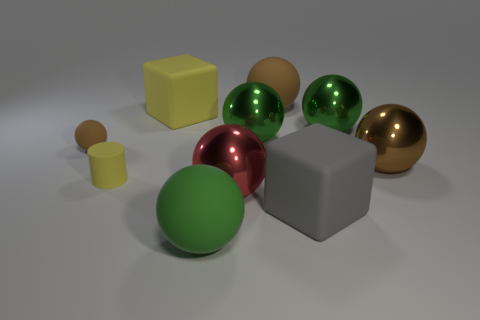Subtract all green spheres. How many were subtracted if there are1green spheres left? 2 Subtract all green cylinders. How many green balls are left? 3 Subtract all red balls. How many balls are left? 6 Subtract all large red shiny spheres. How many spheres are left? 6 Subtract all cyan balls. Subtract all yellow cylinders. How many balls are left? 7 Subtract all blocks. How many objects are left? 8 Subtract all brown balls. Subtract all gray matte objects. How many objects are left? 6 Add 8 yellow cylinders. How many yellow cylinders are left? 9 Add 1 brown rubber things. How many brown rubber things exist? 3 Subtract 1 yellow cylinders. How many objects are left? 9 